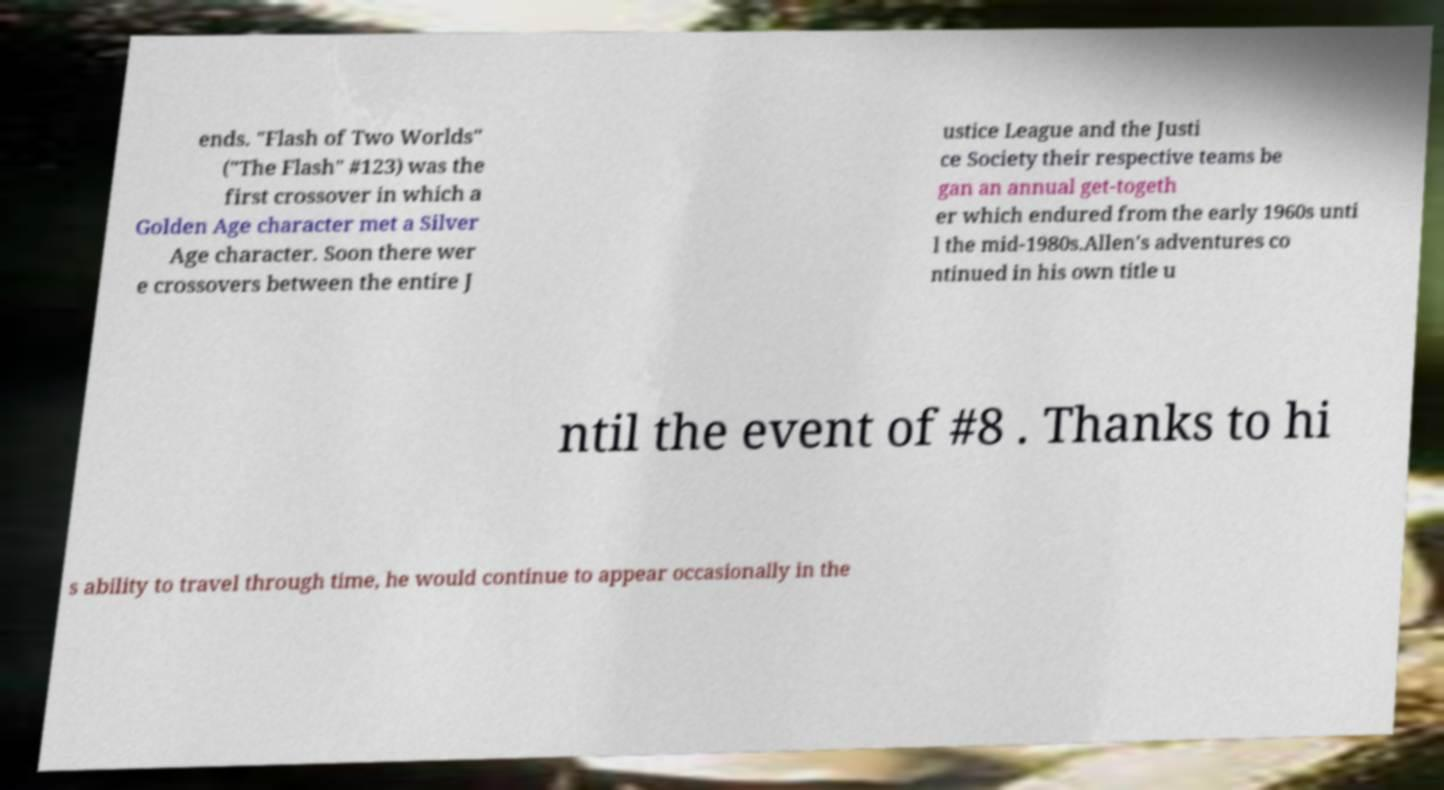Please read and relay the text visible in this image. What does it say? ends. "Flash of Two Worlds" ("The Flash" #123) was the first crossover in which a Golden Age character met a Silver Age character. Soon there wer e crossovers between the entire J ustice League and the Justi ce Society their respective teams be gan an annual get-togeth er which endured from the early 1960s unti l the mid-1980s.Allen's adventures co ntinued in his own title u ntil the event of #8 . Thanks to hi s ability to travel through time, he would continue to appear occasionally in the 